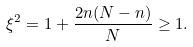Convert formula to latex. <formula><loc_0><loc_0><loc_500><loc_500>\xi ^ { 2 } = 1 + \frac { 2 n ( N - n ) } { N } \geq 1 .</formula> 